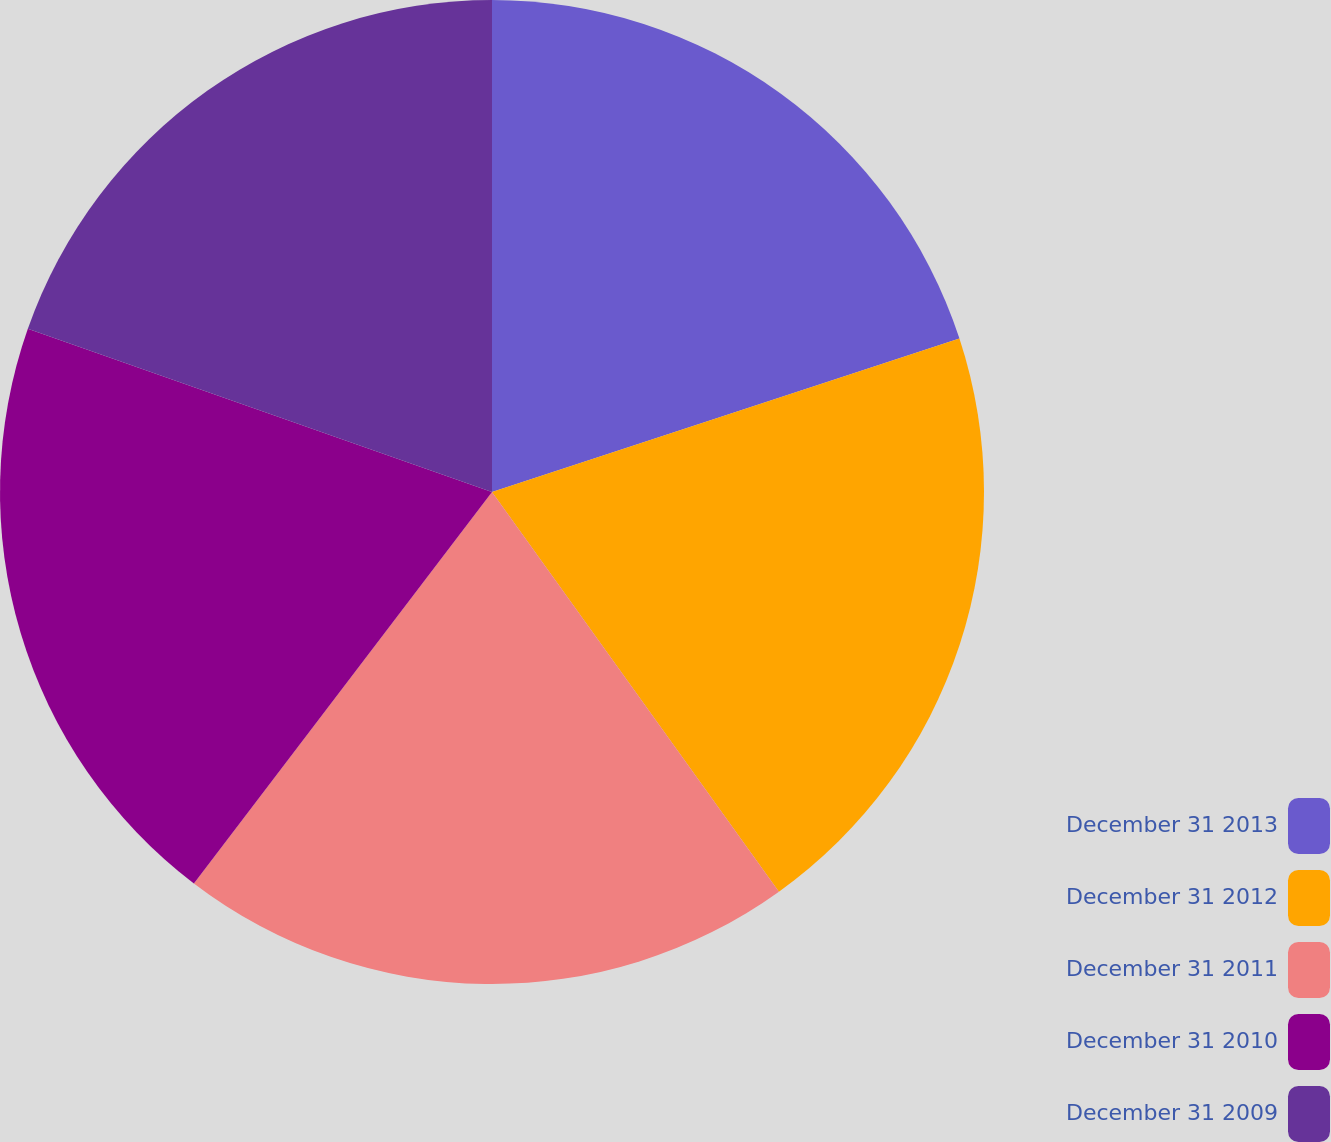Convert chart. <chart><loc_0><loc_0><loc_500><loc_500><pie_chart><fcel>December 31 2013<fcel>December 31 2012<fcel>December 31 2011<fcel>December 31 2010<fcel>December 31 2009<nl><fcel>19.95%<fcel>20.14%<fcel>20.27%<fcel>20.02%<fcel>19.62%<nl></chart> 